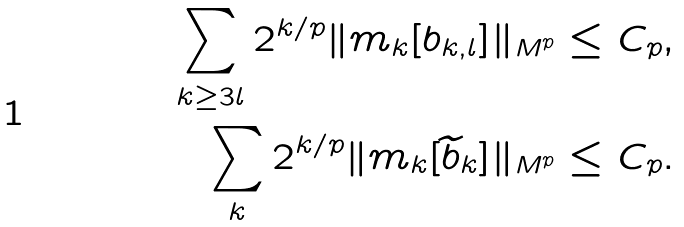Convert formula to latex. <formula><loc_0><loc_0><loc_500><loc_500>\sum _ { k \geq 3 l } 2 ^ { k / p } \| m _ { k } [ b _ { k , l } ] \| _ { M ^ { p } } & \leq C _ { p } , \\ \sum _ { k } 2 ^ { k / p } \| m _ { k } [ \widetilde { b } _ { k } ] \| _ { M ^ { p } } & \leq C _ { p } .</formula> 